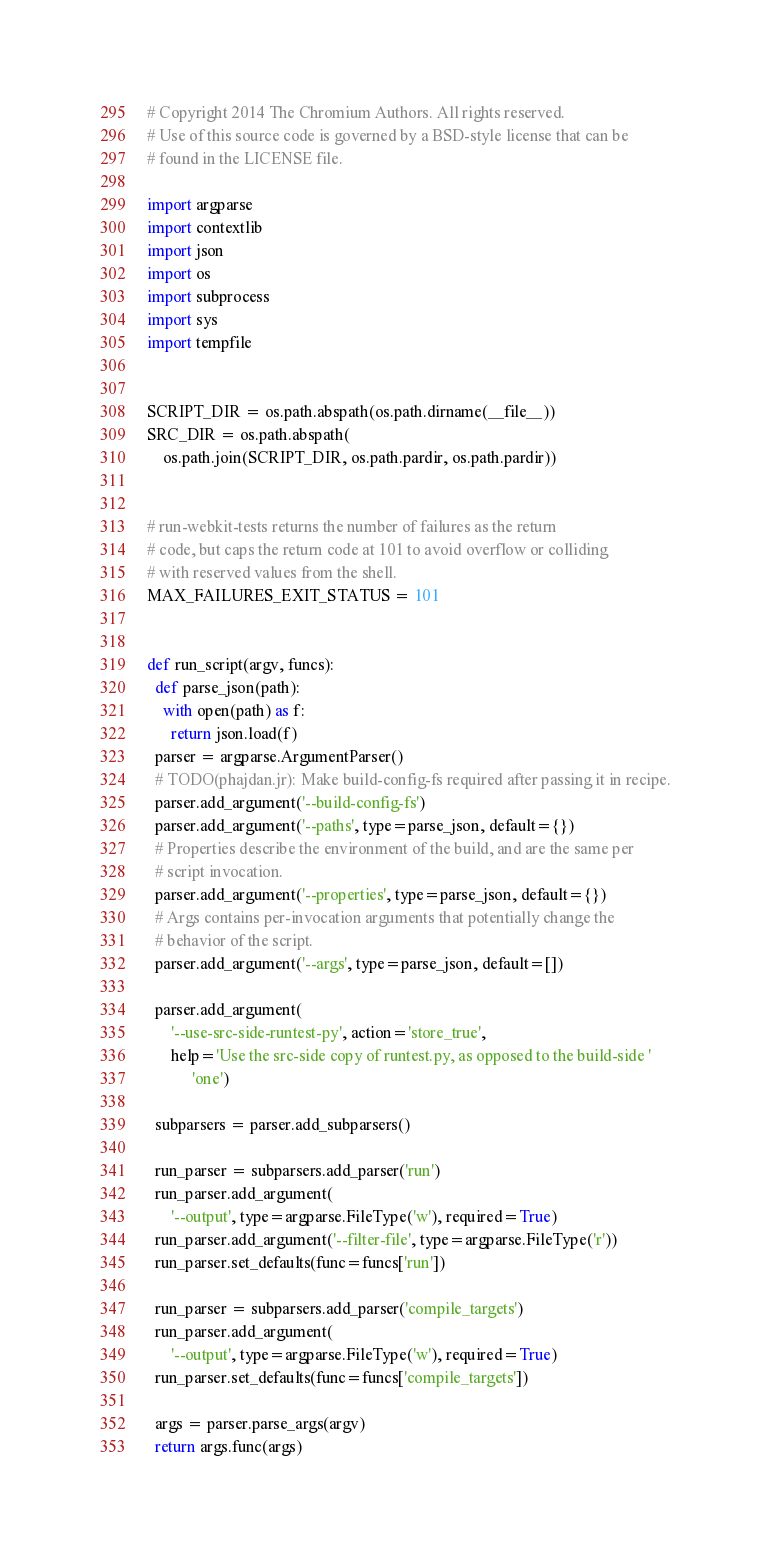Convert code to text. <code><loc_0><loc_0><loc_500><loc_500><_Python_># Copyright 2014 The Chromium Authors. All rights reserved.
# Use of this source code is governed by a BSD-style license that can be
# found in the LICENSE file.

import argparse
import contextlib
import json
import os
import subprocess
import sys
import tempfile


SCRIPT_DIR = os.path.abspath(os.path.dirname(__file__))
SRC_DIR = os.path.abspath(
    os.path.join(SCRIPT_DIR, os.path.pardir, os.path.pardir))


# run-webkit-tests returns the number of failures as the return
# code, but caps the return code at 101 to avoid overflow or colliding
# with reserved values from the shell.
MAX_FAILURES_EXIT_STATUS = 101


def run_script(argv, funcs):
  def parse_json(path):
    with open(path) as f:
      return json.load(f)
  parser = argparse.ArgumentParser()
  # TODO(phajdan.jr): Make build-config-fs required after passing it in recipe.
  parser.add_argument('--build-config-fs')
  parser.add_argument('--paths', type=parse_json, default={})
  # Properties describe the environment of the build, and are the same per
  # script invocation.
  parser.add_argument('--properties', type=parse_json, default={})
  # Args contains per-invocation arguments that potentially change the
  # behavior of the script.
  parser.add_argument('--args', type=parse_json, default=[])

  parser.add_argument(
      '--use-src-side-runtest-py', action='store_true',
      help='Use the src-side copy of runtest.py, as opposed to the build-side '
           'one')

  subparsers = parser.add_subparsers()

  run_parser = subparsers.add_parser('run')
  run_parser.add_argument(
      '--output', type=argparse.FileType('w'), required=True)
  run_parser.add_argument('--filter-file', type=argparse.FileType('r'))
  run_parser.set_defaults(func=funcs['run'])

  run_parser = subparsers.add_parser('compile_targets')
  run_parser.add_argument(
      '--output', type=argparse.FileType('w'), required=True)
  run_parser.set_defaults(func=funcs['compile_targets'])

  args = parser.parse_args(argv)
  return args.func(args)

</code> 